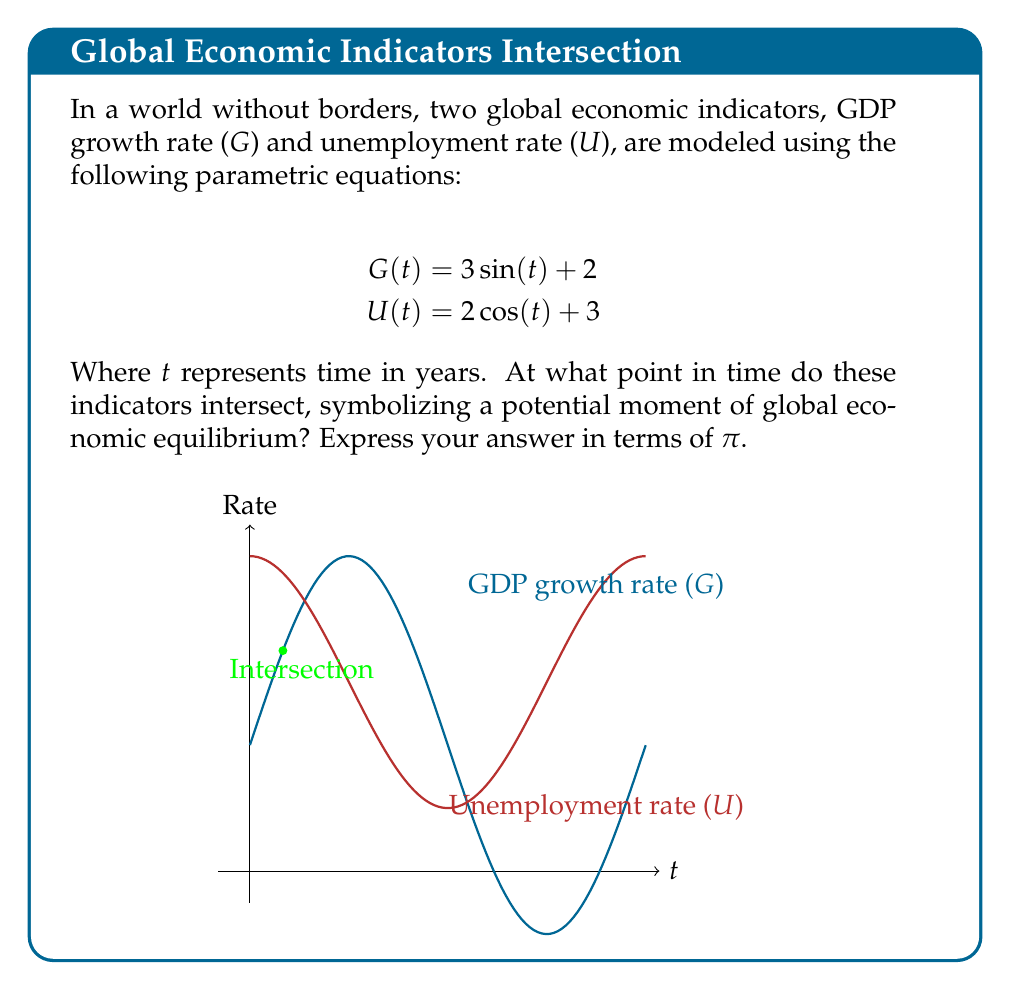What is the answer to this math problem? Let's approach this step-by-step:

1) For the indicators to intersect, their values must be equal at some point t. So, we need to solve:

   $$3\sin(t) + 2 = 2\cos(t) + 3$$

2) Rearranging the equation:

   $$3\sin(t) - 2\cos(t) = 1$$

3) We can solve this using the trigonometric identity:
   
   $$a\sin(t) + b\cos(t) = \sqrt{a^2 + b^2}\sin(t + \arctan(\frac{b}{a}))$$

4) In our case, $a = 3$, $b = -2$. So:

   $$\sqrt{3^2 + (-2)^2}\sin(t + \arctan(\frac{-2}{3})) = 1$$

5) Simplify:

   $$\sqrt{13}\sin(t - \arctan(\frac{2}{3})) = 1$$

6) Solve for t:

   $$t - \arctan(\frac{2}{3}) = \arcsin(\frac{1}{\sqrt{13}})$$

   $$t = \arcsin(\frac{1}{\sqrt{13}}) + \arctan(\frac{2}{3})$$

7) Using a calculator or computer algebra system, we can evaluate this:

   $$t \approx 0.5236$$

8) This value is equal to $\frac{\pi}{6}$ radians.

Therefore, the indicators intersect when $t = \frac{\pi}{6}$ years.
Answer: $\frac{\pi}{6}$ 